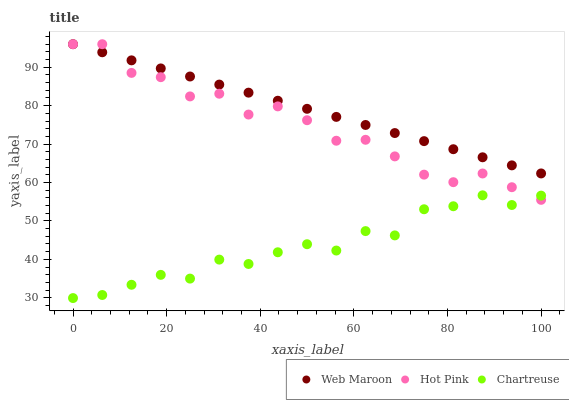Does Chartreuse have the minimum area under the curve?
Answer yes or no. Yes. Does Web Maroon have the maximum area under the curve?
Answer yes or no. Yes. Does Hot Pink have the minimum area under the curve?
Answer yes or no. No. Does Hot Pink have the maximum area under the curve?
Answer yes or no. No. Is Web Maroon the smoothest?
Answer yes or no. Yes. Is Hot Pink the roughest?
Answer yes or no. Yes. Is Hot Pink the smoothest?
Answer yes or no. No. Is Web Maroon the roughest?
Answer yes or no. No. Does Chartreuse have the lowest value?
Answer yes or no. Yes. Does Hot Pink have the lowest value?
Answer yes or no. No. Does Web Maroon have the highest value?
Answer yes or no. Yes. Is Chartreuse less than Web Maroon?
Answer yes or no. Yes. Is Web Maroon greater than Chartreuse?
Answer yes or no. Yes. Does Chartreuse intersect Hot Pink?
Answer yes or no. Yes. Is Chartreuse less than Hot Pink?
Answer yes or no. No. Is Chartreuse greater than Hot Pink?
Answer yes or no. No. Does Chartreuse intersect Web Maroon?
Answer yes or no. No. 